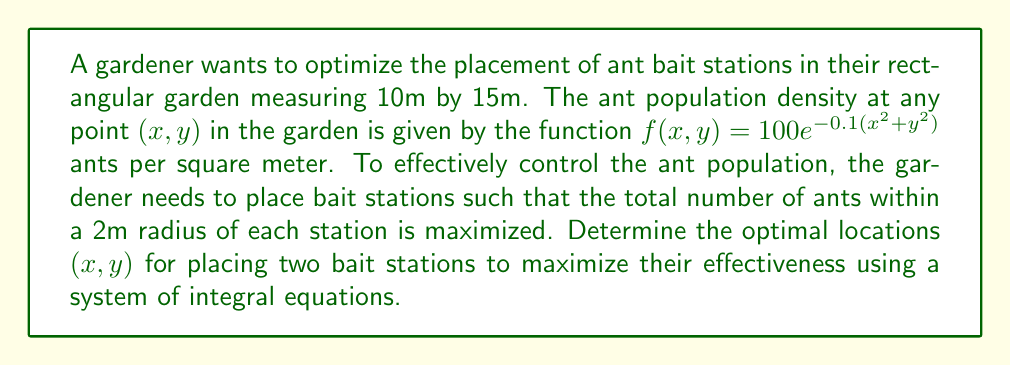Can you solve this math problem? To solve this problem, we'll follow these steps:

1) First, we need to set up an integral that represents the number of ants within a 2m radius of a bait station at position (a,b):

   $$N(a,b) = \int_{a-2}^{a+2} \int_{b-2}^{b+2} f(x,y) dy dx$$

2) Substituting the given function:

   $$N(a,b) = \int_{a-2}^{a+2} \int_{b-2}^{b+2} 100e^{-0.1(x^2+y^2)} dy dx$$

3) To maximize the effectiveness of two bait stations, we need to maximize the sum of the ants covered by each station:

   $$T(a_1,b_1,a_2,b_2) = N(a_1,b_1) + N(a_2,b_2)$$

4) To find the optimal locations, we need to solve the system of equations:

   $$\frac{\partial T}{\partial a_1} = \frac{\partial T}{\partial b_1} = \frac{\partial T}{\partial a_2} = \frac{\partial T}{\partial b_2} = 0$$

5) Due to the symmetry of the garden and the ant density function, we can deduce that the optimal locations will be symmetrical about the center of the garden. Let's place the stations at (5±d, 7.5), where d is the distance from the center.

6) Now our problem reduces to maximizing:

   $$T(d) = 2N(5+d, 7.5)$$

7) Solving $\frac{dT}{dd} = 0$ numerically (as the integral doesn't have a closed-form solution), we find that the maximum occurs at d ≈ 2.8m.

8) Therefore, the optimal locations for the two bait stations are approximately (2.2m, 7.5m) and (7.8m, 7.5m).
Answer: (2.2, 7.5) and (7.8, 7.5) 